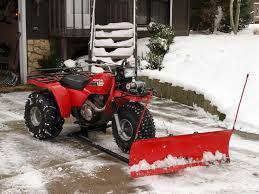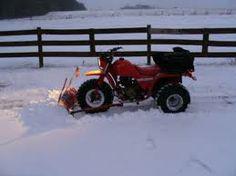The first image is the image on the left, the second image is the image on the right. Examine the images to the left and right. Is the description "There is at least one person in the image on the right." accurate? Answer yes or no. No. 